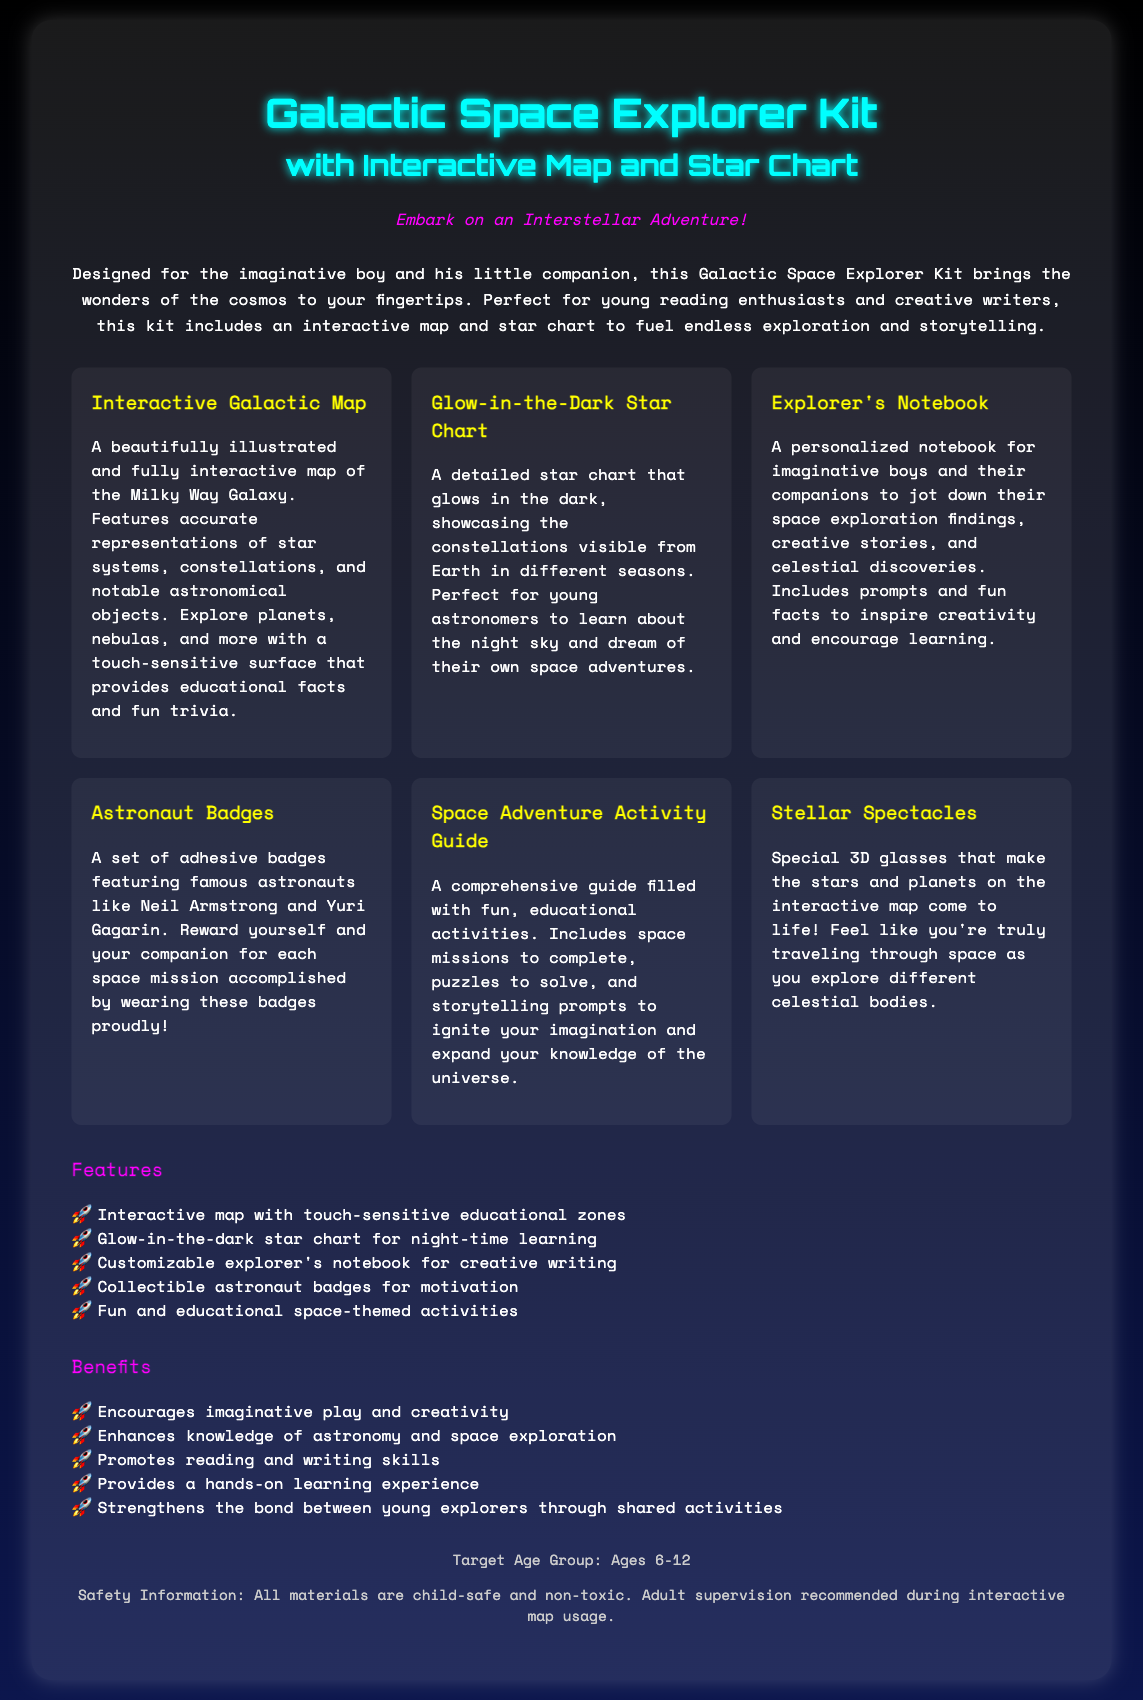What is included in the Galactic Space Explorer Kit? The kit includes an interactive map, star chart, explorer's notebook, astronaut badges, activity guide, and stellar spectacles.
Answer: interactive map, star chart, explorer's notebook, astronaut badges, activity guide, stellar spectacles What age group is the Galactic Space Explorer Kit targeted at? The document specifies the target age group for the kit.
Answer: Ages 6-12 What feature allows the map to provide educational facts? The interactive features of the galactic map use touch-sensitive technology to deliver information.
Answer: touch-sensitive educational zones What types of activities are in the Space Adventure Activity Guide? The guide includes various fun and educational activities such as puzzles, missions, and storytelling prompts.
Answer: puzzles, missions, storytelling prompts What benefit does the kit provide regarding reading skills? The document outlines how the Galactic Space Explorer Kit promotes certain skills, including reading.
Answer: Promotes reading What type of chart glows in the dark? The document specifically describes a chart that has this characteristic.
Answer: Glow-in-the-Dark Star Chart How does the Explorer's Notebook help encourage creativity? The notebook includes prompts and fun facts designed specifically to inspire creative thinking.
Answer: prompts and fun facts What kind of errors in the kit does adult supervision help prevent? The document mentions a safety recommendation regarding interaction with one of the items.
Answer: interactive map usage 